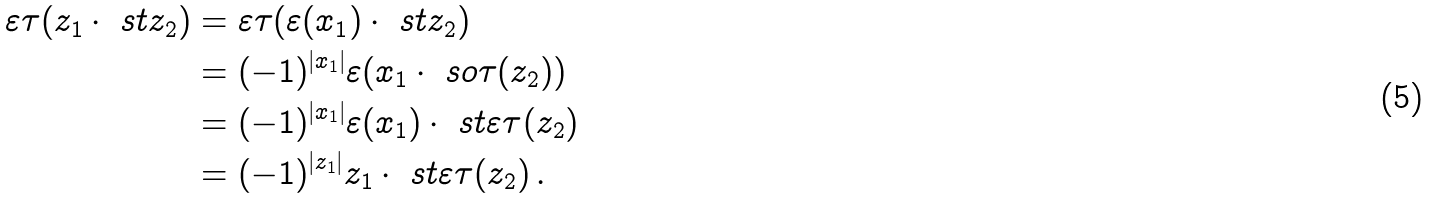<formula> <loc_0><loc_0><loc_500><loc_500>\varepsilon \tau ( z _ { 1 } \cdot \ s t z _ { 2 } ) & = \varepsilon \tau ( \varepsilon ( x _ { 1 } ) \cdot \ s t z _ { 2 } ) \\ & = ( - 1 ) ^ { | x _ { 1 } | } \varepsilon ( x _ { 1 } \cdot \ s o \tau ( z _ { 2 } ) ) \\ & = ( - 1 ) ^ { | x _ { 1 } | } \varepsilon ( x _ { 1 } ) \cdot \ s t \varepsilon \tau ( z _ { 2 } ) \\ & = ( - 1 ) ^ { | z _ { 1 } | } z _ { 1 } \cdot \ s t \varepsilon \tau ( z _ { 2 } ) \, .</formula> 